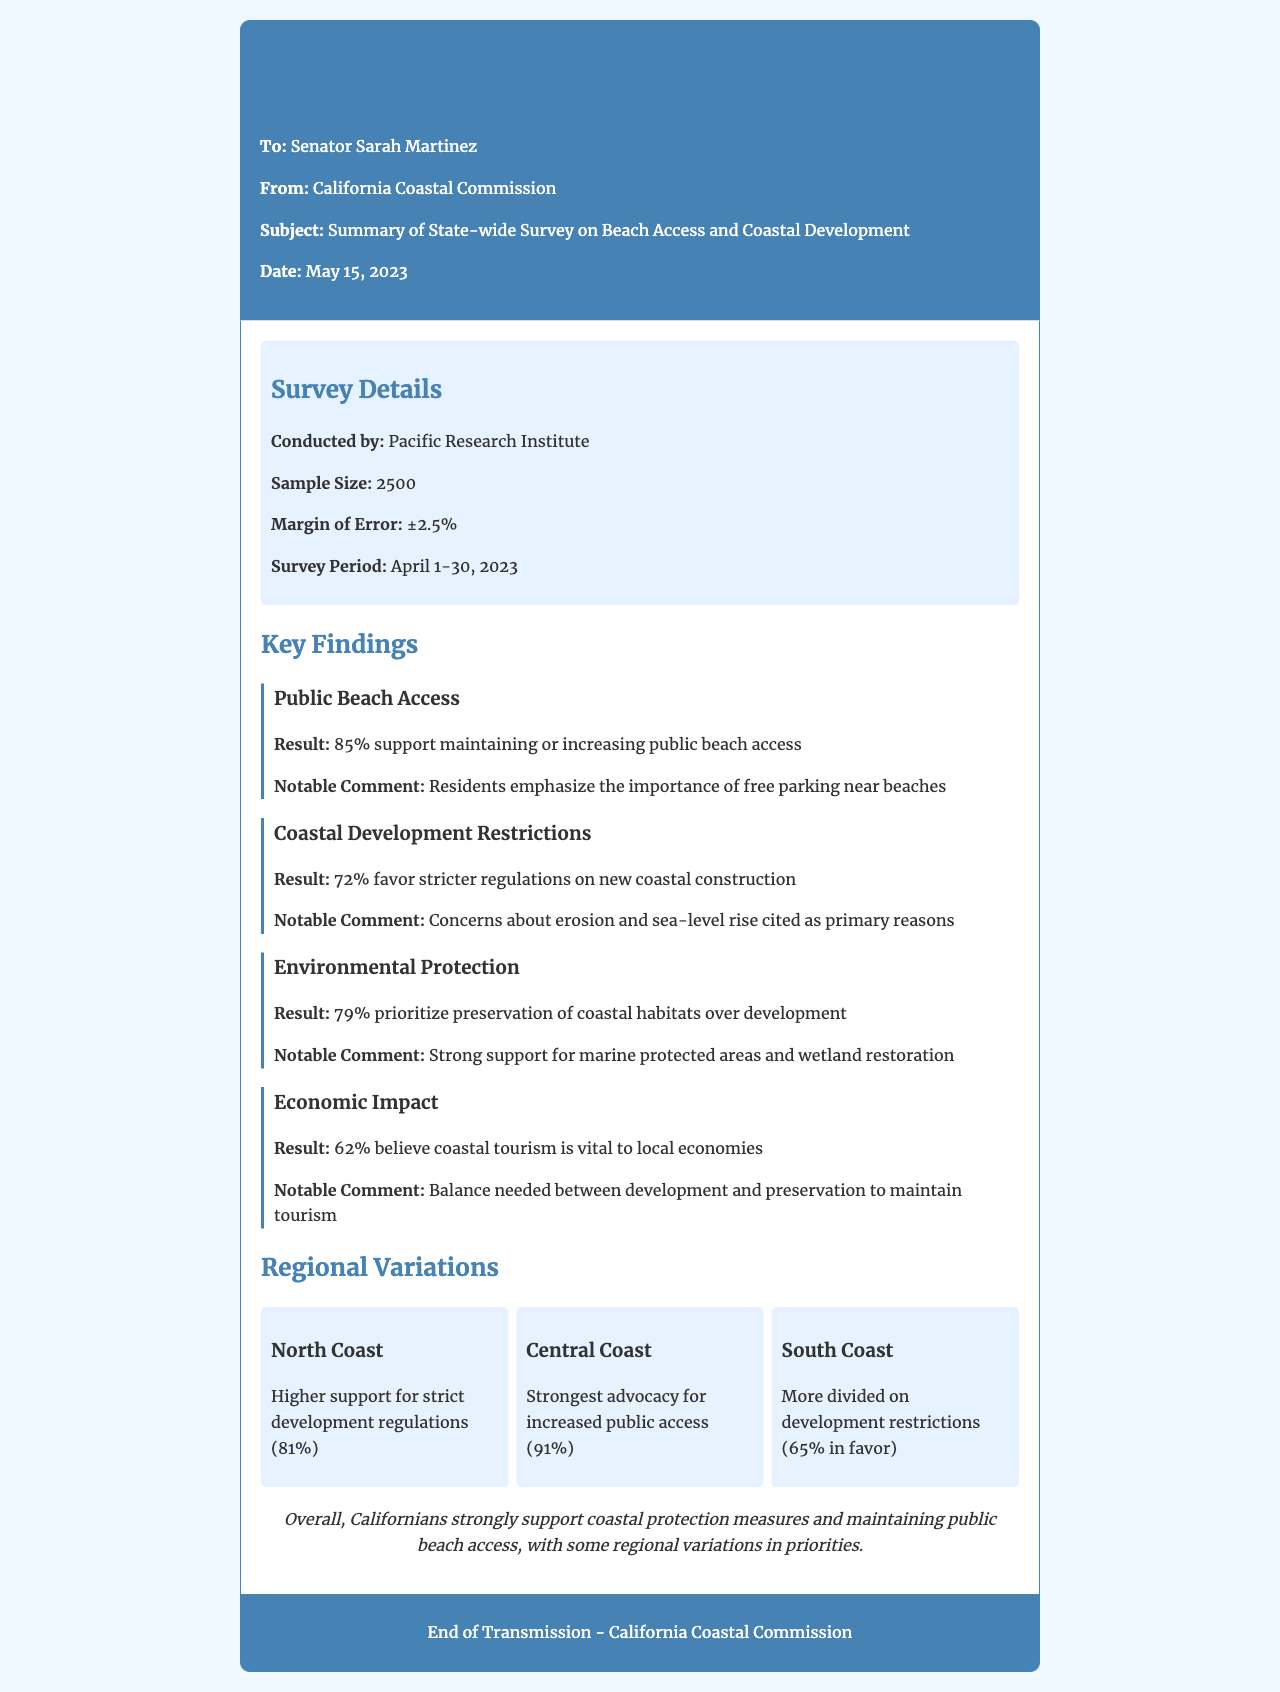what is the sample size of the survey? The sample size is mentioned in the survey details section of the document, which lists it as 2500.
Answer: 2500 who conducted the survey? The document states that the survey was conducted by the Pacific Research Institute.
Answer: Pacific Research Institute what percentage of respondents support maintaining or increasing public beach access? This information is found in the key findings on public beach access, which indicates 85% support.
Answer: 85% what is the margin of error of the survey? The margin of error is specified in the survey details, indicating it is ±2.5%.
Answer: ±2.5% which coastal region shows the strongest advocacy for increased public access? The Central Coast region is highlighted for its strong advocacy for increased public access in the regional variations section, stating 91% support.
Answer: Central Coast what are the primary concerns leading to favor stricter coastal development regulations? The key findings state that concerns about erosion and sea-level rise are cited as primary reasons for favoring stricter regulations.
Answer: Erosion and sea-level rise what percentage of respondents believe coastal tourism is vital to local economies? The economic impact section of the key findings indicates that 62% believe coastal tourism is vital.
Answer: 62% how do respondents prioritize the preservation of coastal habitats over development? The survey results state that 79% prioritize preservation over development, as noted in the environmental protection key finding.
Answer: 79% what notable comment is associated with environmental protection? The document highlights strong support for marine protected areas and wetland restoration in the notable comments related to environmental protection.
Answer: Marine protected areas and wetland restoration 